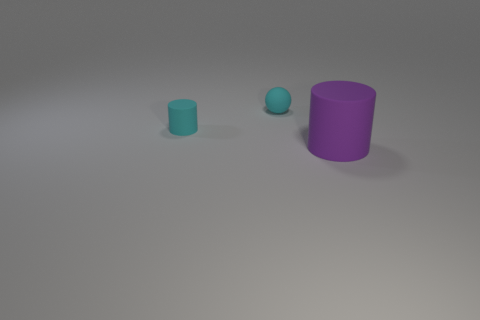Is the shape of the big matte thing the same as the small object on the right side of the small cyan matte cylinder?
Make the answer very short. No. Is there another matte object that has the same shape as the big object?
Make the answer very short. Yes. How many objects are matte cylinders that are left of the large matte cylinder or matte things on the right side of the small matte ball?
Ensure brevity in your answer.  2. How many other tiny cylinders are the same color as the tiny matte cylinder?
Give a very brief answer. 0. What is the color of the other thing that is the same shape as the large purple rubber thing?
Provide a short and direct response. Cyan. What is the shape of the matte object that is both on the right side of the tiny cyan cylinder and left of the purple cylinder?
Your answer should be very brief. Sphere. Are there more cyan balls than objects?
Offer a very short reply. No. What is the material of the big purple object?
Provide a short and direct response. Rubber. Is there any other thing that has the same size as the purple cylinder?
Your response must be concise. No. There is a rubber object behind the cyan matte cylinder; are there any rubber cylinders on the right side of it?
Offer a terse response. Yes. 